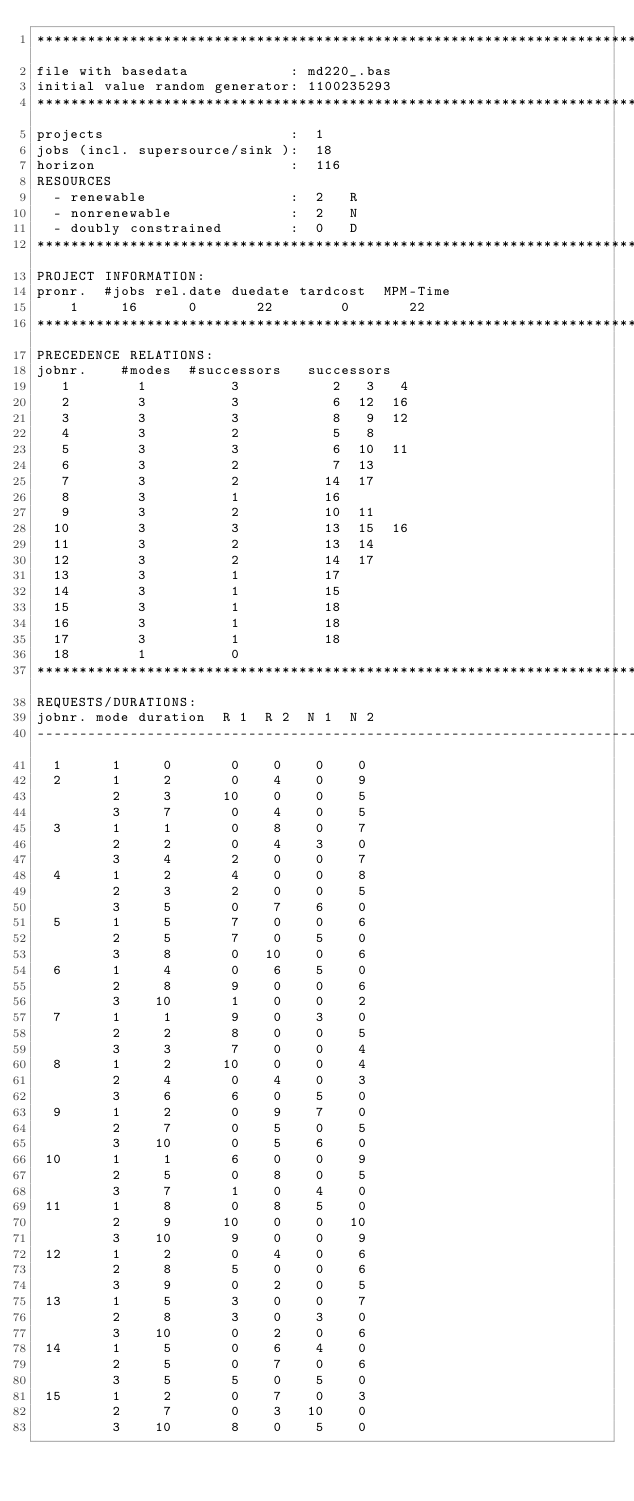Convert code to text. <code><loc_0><loc_0><loc_500><loc_500><_ObjectiveC_>************************************************************************
file with basedata            : md220_.bas
initial value random generator: 1100235293
************************************************************************
projects                      :  1
jobs (incl. supersource/sink ):  18
horizon                       :  116
RESOURCES
  - renewable                 :  2   R
  - nonrenewable              :  2   N
  - doubly constrained        :  0   D
************************************************************************
PROJECT INFORMATION:
pronr.  #jobs rel.date duedate tardcost  MPM-Time
    1     16      0       22        0       22
************************************************************************
PRECEDENCE RELATIONS:
jobnr.    #modes  #successors   successors
   1        1          3           2   3   4
   2        3          3           6  12  16
   3        3          3           8   9  12
   4        3          2           5   8
   5        3          3           6  10  11
   6        3          2           7  13
   7        3          2          14  17
   8        3          1          16
   9        3          2          10  11
  10        3          3          13  15  16
  11        3          2          13  14
  12        3          2          14  17
  13        3          1          17
  14        3          1          15
  15        3          1          18
  16        3          1          18
  17        3          1          18
  18        1          0        
************************************************************************
REQUESTS/DURATIONS:
jobnr. mode duration  R 1  R 2  N 1  N 2
------------------------------------------------------------------------
  1      1     0       0    0    0    0
  2      1     2       0    4    0    9
         2     3      10    0    0    5
         3     7       0    4    0    5
  3      1     1       0    8    0    7
         2     2       0    4    3    0
         3     4       2    0    0    7
  4      1     2       4    0    0    8
         2     3       2    0    0    5
         3     5       0    7    6    0
  5      1     5       7    0    0    6
         2     5       7    0    5    0
         3     8       0   10    0    6
  6      1     4       0    6    5    0
         2     8       9    0    0    6
         3    10       1    0    0    2
  7      1     1       9    0    3    0
         2     2       8    0    0    5
         3     3       7    0    0    4
  8      1     2      10    0    0    4
         2     4       0    4    0    3
         3     6       6    0    5    0
  9      1     2       0    9    7    0
         2     7       0    5    0    5
         3    10       0    5    6    0
 10      1     1       6    0    0    9
         2     5       0    8    0    5
         3     7       1    0    4    0
 11      1     8       0    8    5    0
         2     9      10    0    0   10
         3    10       9    0    0    9
 12      1     2       0    4    0    6
         2     8       5    0    0    6
         3     9       0    2    0    5
 13      1     5       3    0    0    7
         2     8       3    0    3    0
         3    10       0    2    0    6
 14      1     5       0    6    4    0
         2     5       0    7    0    6
         3     5       5    0    5    0
 15      1     2       0    7    0    3
         2     7       0    3   10    0
         3    10       8    0    5    0</code> 